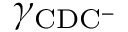Convert formula to latex. <formula><loc_0><loc_0><loc_500><loc_500>\gamma _ { C D C ^ { - } }</formula> 